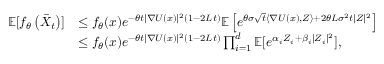Convert formula to latex. <formula><loc_0><loc_0><loc_500><loc_500>\begin{array} { r l } { \mathbb { E } [ f _ { \theta } \left ( \bar { X } _ { t } \right ) ] } & { \leq f _ { \theta } ( x ) e ^ { - \theta t | \nabla U ( x ) | ^ { 2 } ( 1 - 2 L t ) } \mathbb { E } \left [ e ^ { \theta \sigma \sqrt { t } \langle \nabla U ( x ) , Z \rangle + 2 \theta L \sigma ^ { 2 } t | Z | ^ { 2 } } \right ] } \\ & { \leq f _ { \theta } ( x ) e ^ { - \theta t | \nabla U ( x ) | ^ { 2 } ( 1 - 2 L t ) } \prod _ { i = 1 } ^ { d } \mathbb { E } [ e ^ { \alpha _ { i } Z _ { i } + \beta _ { i } | Z _ { i } | ^ { 2 } } ] , } \end{array}</formula> 